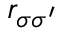<formula> <loc_0><loc_0><loc_500><loc_500>r _ { \sigma \sigma ^ { \prime } }</formula> 